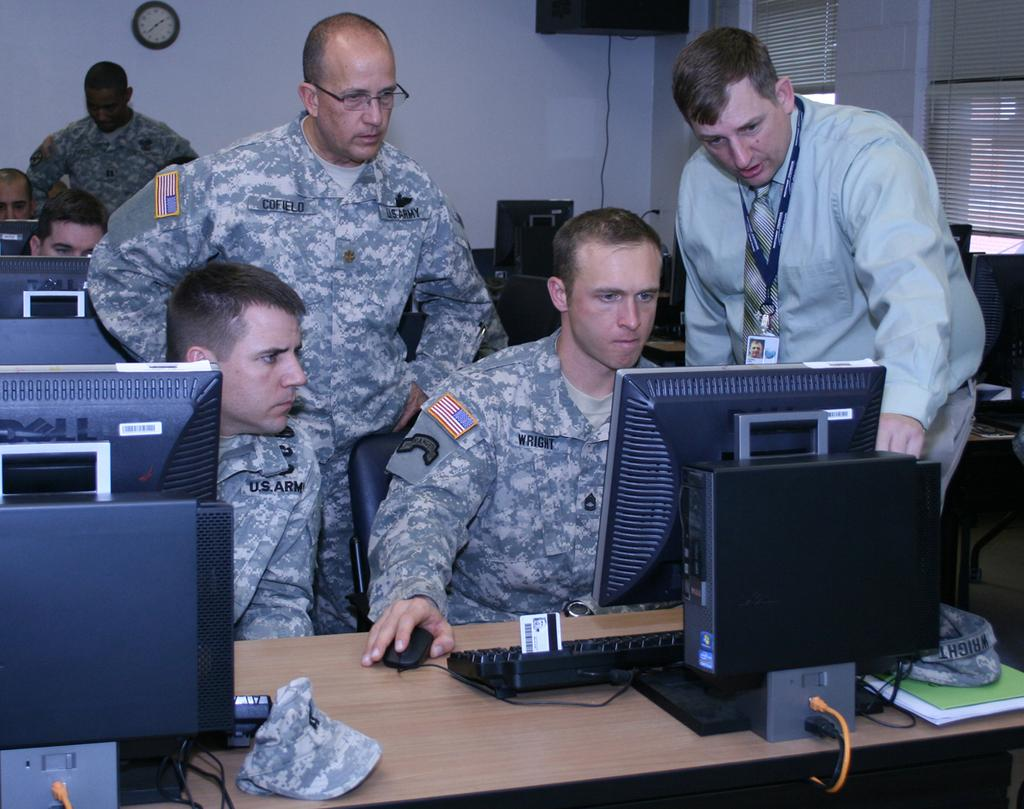<image>
Share a concise interpretation of the image provided. Three men looking at a computer monitor and one of their tags saying Cofield. 